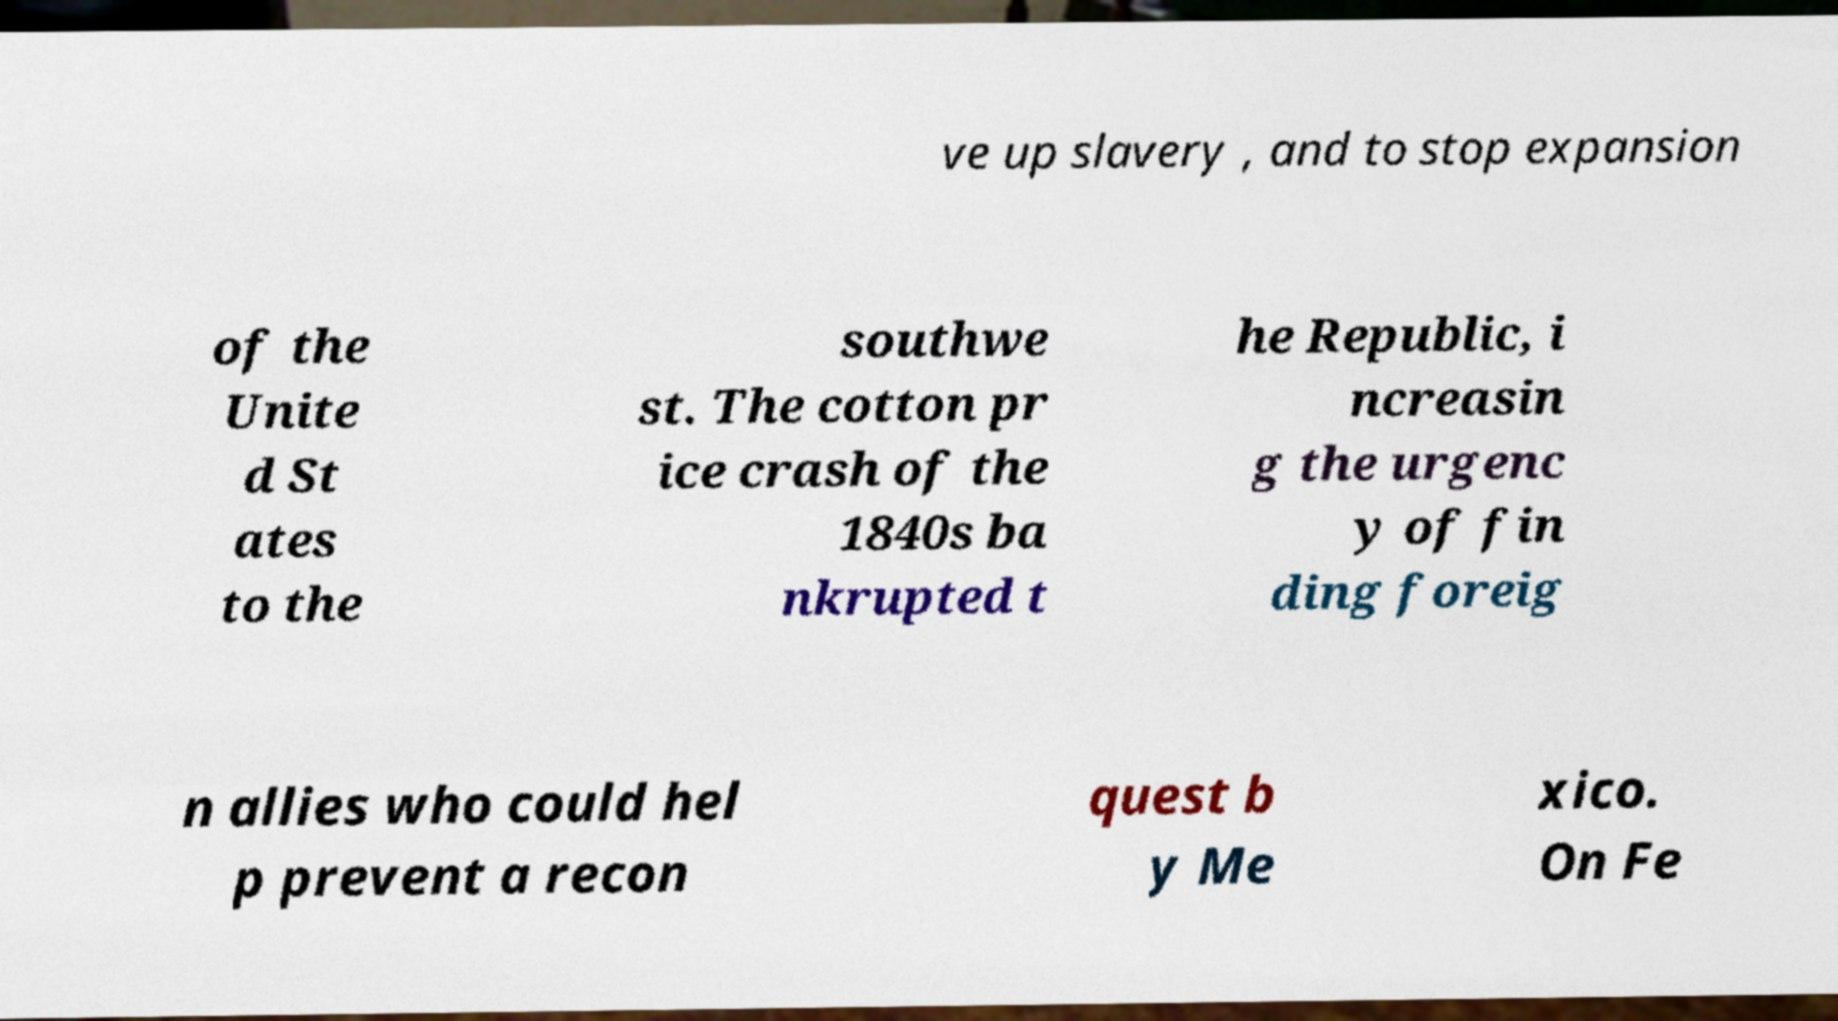Could you assist in decoding the text presented in this image and type it out clearly? ve up slavery , and to stop expansion of the Unite d St ates to the southwe st. The cotton pr ice crash of the 1840s ba nkrupted t he Republic, i ncreasin g the urgenc y of fin ding foreig n allies who could hel p prevent a recon quest b y Me xico. On Fe 